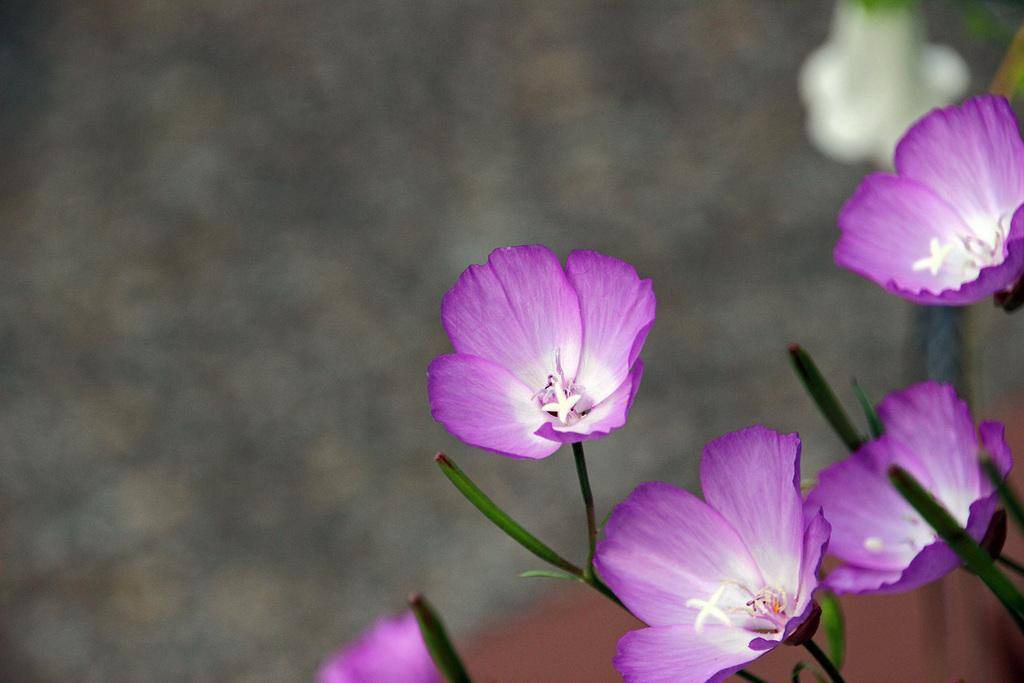What type of living organisms can be seen in the image? There are flowers in the image. How are the flowers connected to their stems? The flowers are attached to stems. What can be observed about the background of the image? The background of the image is blurred. What emotion is the flower expressing in the image? Flowers do not express emotions, so this question cannot be answered definitively from the image. 